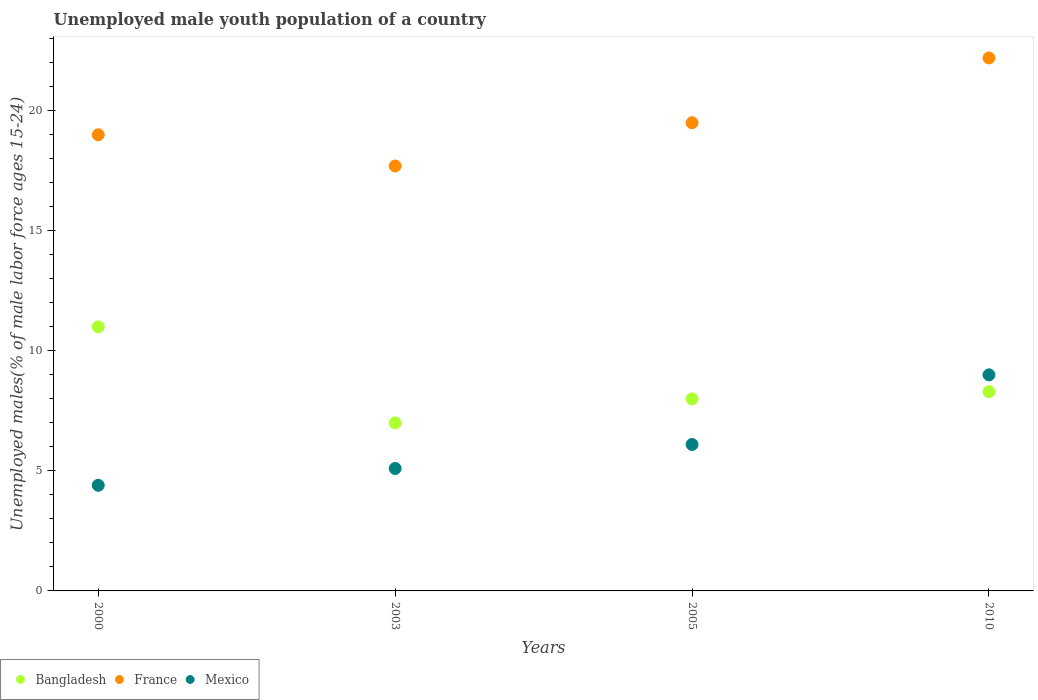What is the percentage of unemployed male youth population in France in 2005?
Offer a terse response. 19.5. Across all years, what is the maximum percentage of unemployed male youth population in Mexico?
Keep it short and to the point. 9. Across all years, what is the minimum percentage of unemployed male youth population in Bangladesh?
Make the answer very short. 7. In which year was the percentage of unemployed male youth population in France maximum?
Your answer should be compact. 2010. What is the total percentage of unemployed male youth population in Mexico in the graph?
Provide a succinct answer. 24.6. What is the difference between the percentage of unemployed male youth population in Bangladesh in 2000 and the percentage of unemployed male youth population in France in 2010?
Your answer should be compact. -11.2. What is the average percentage of unemployed male youth population in Bangladesh per year?
Provide a short and direct response. 8.58. In the year 2005, what is the difference between the percentage of unemployed male youth population in France and percentage of unemployed male youth population in Mexico?
Your response must be concise. 13.4. In how many years, is the percentage of unemployed male youth population in France greater than 13 %?
Offer a terse response. 4. What is the ratio of the percentage of unemployed male youth population in Mexico in 2000 to that in 2003?
Offer a terse response. 0.86. Is the difference between the percentage of unemployed male youth population in France in 2005 and 2010 greater than the difference between the percentage of unemployed male youth population in Mexico in 2005 and 2010?
Give a very brief answer. Yes. What is the difference between the highest and the second highest percentage of unemployed male youth population in France?
Make the answer very short. 2.7. In how many years, is the percentage of unemployed male youth population in Bangladesh greater than the average percentage of unemployed male youth population in Bangladesh taken over all years?
Your answer should be compact. 1. Is the sum of the percentage of unemployed male youth population in Bangladesh in 2000 and 2003 greater than the maximum percentage of unemployed male youth population in France across all years?
Make the answer very short. No. Is it the case that in every year, the sum of the percentage of unemployed male youth population in France and percentage of unemployed male youth population in Mexico  is greater than the percentage of unemployed male youth population in Bangladesh?
Ensure brevity in your answer.  Yes. Does the percentage of unemployed male youth population in Mexico monotonically increase over the years?
Your answer should be compact. Yes. Is the percentage of unemployed male youth population in France strictly greater than the percentage of unemployed male youth population in Bangladesh over the years?
Offer a very short reply. Yes. Is the percentage of unemployed male youth population in Mexico strictly less than the percentage of unemployed male youth population in France over the years?
Your response must be concise. Yes. How many years are there in the graph?
Offer a terse response. 4. What is the difference between two consecutive major ticks on the Y-axis?
Give a very brief answer. 5. Are the values on the major ticks of Y-axis written in scientific E-notation?
Give a very brief answer. No. Does the graph contain any zero values?
Provide a short and direct response. No. Where does the legend appear in the graph?
Ensure brevity in your answer.  Bottom left. How are the legend labels stacked?
Make the answer very short. Horizontal. What is the title of the graph?
Give a very brief answer. Unemployed male youth population of a country. Does "Sudan" appear as one of the legend labels in the graph?
Ensure brevity in your answer.  No. What is the label or title of the Y-axis?
Provide a succinct answer. Unemployed males(% of male labor force ages 15-24). What is the Unemployed males(% of male labor force ages 15-24) in Bangladesh in 2000?
Provide a succinct answer. 11. What is the Unemployed males(% of male labor force ages 15-24) in France in 2000?
Offer a terse response. 19. What is the Unemployed males(% of male labor force ages 15-24) in Mexico in 2000?
Your answer should be compact. 4.4. What is the Unemployed males(% of male labor force ages 15-24) in Bangladesh in 2003?
Give a very brief answer. 7. What is the Unemployed males(% of male labor force ages 15-24) of France in 2003?
Offer a very short reply. 17.7. What is the Unemployed males(% of male labor force ages 15-24) in Mexico in 2003?
Ensure brevity in your answer.  5.1. What is the Unemployed males(% of male labor force ages 15-24) of Bangladesh in 2005?
Your answer should be very brief. 8. What is the Unemployed males(% of male labor force ages 15-24) in France in 2005?
Your response must be concise. 19.5. What is the Unemployed males(% of male labor force ages 15-24) in Mexico in 2005?
Offer a terse response. 6.1. What is the Unemployed males(% of male labor force ages 15-24) of Bangladesh in 2010?
Your response must be concise. 8.3. What is the Unemployed males(% of male labor force ages 15-24) of France in 2010?
Give a very brief answer. 22.2. What is the Unemployed males(% of male labor force ages 15-24) in Mexico in 2010?
Your answer should be very brief. 9. Across all years, what is the maximum Unemployed males(% of male labor force ages 15-24) in Bangladesh?
Provide a short and direct response. 11. Across all years, what is the maximum Unemployed males(% of male labor force ages 15-24) in France?
Give a very brief answer. 22.2. Across all years, what is the maximum Unemployed males(% of male labor force ages 15-24) in Mexico?
Your answer should be very brief. 9. Across all years, what is the minimum Unemployed males(% of male labor force ages 15-24) in Bangladesh?
Offer a terse response. 7. Across all years, what is the minimum Unemployed males(% of male labor force ages 15-24) in France?
Your answer should be very brief. 17.7. Across all years, what is the minimum Unemployed males(% of male labor force ages 15-24) in Mexico?
Offer a very short reply. 4.4. What is the total Unemployed males(% of male labor force ages 15-24) in Bangladesh in the graph?
Make the answer very short. 34.3. What is the total Unemployed males(% of male labor force ages 15-24) in France in the graph?
Your answer should be compact. 78.4. What is the total Unemployed males(% of male labor force ages 15-24) in Mexico in the graph?
Give a very brief answer. 24.6. What is the difference between the Unemployed males(% of male labor force ages 15-24) of Bangladesh in 2000 and that in 2005?
Your response must be concise. 3. What is the difference between the Unemployed males(% of male labor force ages 15-24) in Mexico in 2000 and that in 2005?
Keep it short and to the point. -1.7. What is the difference between the Unemployed males(% of male labor force ages 15-24) of France in 2000 and that in 2010?
Give a very brief answer. -3.2. What is the difference between the Unemployed males(% of male labor force ages 15-24) of Mexico in 2003 and that in 2005?
Offer a very short reply. -1. What is the difference between the Unemployed males(% of male labor force ages 15-24) of Mexico in 2003 and that in 2010?
Your answer should be compact. -3.9. What is the difference between the Unemployed males(% of male labor force ages 15-24) of Bangladesh in 2005 and that in 2010?
Your response must be concise. -0.3. What is the difference between the Unemployed males(% of male labor force ages 15-24) in Bangladesh in 2000 and the Unemployed males(% of male labor force ages 15-24) in France in 2003?
Ensure brevity in your answer.  -6.7. What is the difference between the Unemployed males(% of male labor force ages 15-24) of France in 2000 and the Unemployed males(% of male labor force ages 15-24) of Mexico in 2003?
Give a very brief answer. 13.9. What is the difference between the Unemployed males(% of male labor force ages 15-24) in Bangladesh in 2000 and the Unemployed males(% of male labor force ages 15-24) in France in 2005?
Your answer should be very brief. -8.5. What is the difference between the Unemployed males(% of male labor force ages 15-24) of Bangladesh in 2000 and the Unemployed males(% of male labor force ages 15-24) of Mexico in 2010?
Ensure brevity in your answer.  2. What is the difference between the Unemployed males(% of male labor force ages 15-24) in Bangladesh in 2003 and the Unemployed males(% of male labor force ages 15-24) in France in 2005?
Offer a very short reply. -12.5. What is the difference between the Unemployed males(% of male labor force ages 15-24) in Bangladesh in 2003 and the Unemployed males(% of male labor force ages 15-24) in France in 2010?
Your answer should be compact. -15.2. What is the difference between the Unemployed males(% of male labor force ages 15-24) of Bangladesh in 2003 and the Unemployed males(% of male labor force ages 15-24) of Mexico in 2010?
Provide a succinct answer. -2. What is the difference between the Unemployed males(% of male labor force ages 15-24) in France in 2005 and the Unemployed males(% of male labor force ages 15-24) in Mexico in 2010?
Ensure brevity in your answer.  10.5. What is the average Unemployed males(% of male labor force ages 15-24) of Bangladesh per year?
Your answer should be very brief. 8.57. What is the average Unemployed males(% of male labor force ages 15-24) of France per year?
Your answer should be compact. 19.6. What is the average Unemployed males(% of male labor force ages 15-24) in Mexico per year?
Offer a very short reply. 6.15. In the year 2000, what is the difference between the Unemployed males(% of male labor force ages 15-24) of Bangladesh and Unemployed males(% of male labor force ages 15-24) of Mexico?
Offer a terse response. 6.6. In the year 2000, what is the difference between the Unemployed males(% of male labor force ages 15-24) in France and Unemployed males(% of male labor force ages 15-24) in Mexico?
Give a very brief answer. 14.6. In the year 2003, what is the difference between the Unemployed males(% of male labor force ages 15-24) of Bangladesh and Unemployed males(% of male labor force ages 15-24) of France?
Keep it short and to the point. -10.7. In the year 2010, what is the difference between the Unemployed males(% of male labor force ages 15-24) of Bangladesh and Unemployed males(% of male labor force ages 15-24) of Mexico?
Ensure brevity in your answer.  -0.7. What is the ratio of the Unemployed males(% of male labor force ages 15-24) of Bangladesh in 2000 to that in 2003?
Provide a succinct answer. 1.57. What is the ratio of the Unemployed males(% of male labor force ages 15-24) in France in 2000 to that in 2003?
Give a very brief answer. 1.07. What is the ratio of the Unemployed males(% of male labor force ages 15-24) of Mexico in 2000 to that in 2003?
Give a very brief answer. 0.86. What is the ratio of the Unemployed males(% of male labor force ages 15-24) of Bangladesh in 2000 to that in 2005?
Your answer should be very brief. 1.38. What is the ratio of the Unemployed males(% of male labor force ages 15-24) in France in 2000 to that in 2005?
Keep it short and to the point. 0.97. What is the ratio of the Unemployed males(% of male labor force ages 15-24) in Mexico in 2000 to that in 2005?
Your answer should be compact. 0.72. What is the ratio of the Unemployed males(% of male labor force ages 15-24) in Bangladesh in 2000 to that in 2010?
Keep it short and to the point. 1.33. What is the ratio of the Unemployed males(% of male labor force ages 15-24) of France in 2000 to that in 2010?
Give a very brief answer. 0.86. What is the ratio of the Unemployed males(% of male labor force ages 15-24) of Mexico in 2000 to that in 2010?
Offer a terse response. 0.49. What is the ratio of the Unemployed males(% of male labor force ages 15-24) of France in 2003 to that in 2005?
Offer a terse response. 0.91. What is the ratio of the Unemployed males(% of male labor force ages 15-24) in Mexico in 2003 to that in 2005?
Provide a short and direct response. 0.84. What is the ratio of the Unemployed males(% of male labor force ages 15-24) in Bangladesh in 2003 to that in 2010?
Offer a very short reply. 0.84. What is the ratio of the Unemployed males(% of male labor force ages 15-24) of France in 2003 to that in 2010?
Provide a succinct answer. 0.8. What is the ratio of the Unemployed males(% of male labor force ages 15-24) in Mexico in 2003 to that in 2010?
Offer a very short reply. 0.57. What is the ratio of the Unemployed males(% of male labor force ages 15-24) in Bangladesh in 2005 to that in 2010?
Your answer should be compact. 0.96. What is the ratio of the Unemployed males(% of male labor force ages 15-24) of France in 2005 to that in 2010?
Your response must be concise. 0.88. What is the ratio of the Unemployed males(% of male labor force ages 15-24) in Mexico in 2005 to that in 2010?
Make the answer very short. 0.68. What is the difference between the highest and the second highest Unemployed males(% of male labor force ages 15-24) of Bangladesh?
Keep it short and to the point. 2.7. What is the difference between the highest and the lowest Unemployed males(% of male labor force ages 15-24) in Mexico?
Offer a very short reply. 4.6. 